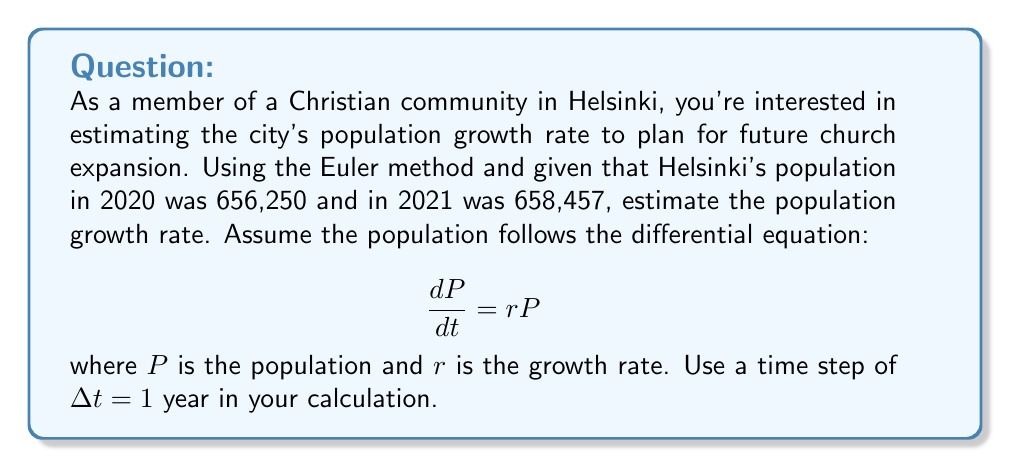Provide a solution to this math problem. To estimate the population growth rate using the Euler method:

1. The Euler method for this differential equation is:
   $$P_{n+1} = P_n + r P_n \Delta t$$

2. We know:
   $P_0 = 656,250$ (2020 population)
   $P_1 = 658,457$ (2021 population)
   $\Delta t = 1$ year

3. Substitute these values into the Euler formula:
   $$658,457 = 656,250 + r(656,250)(1)$$

4. Solve for $r$:
   $$658,457 - 656,250 = 656,250r$$
   $$2,207 = 656,250r$$
   $$r = \frac{2,207}{656,250}$$

5. Calculate $r$:
   $$r \approx 0.003362 \text{ or } 0.3362\%$$

This represents the estimated annual population growth rate for Helsinki.
Answer: $r \approx 0.003362$ or $0.3362\%$ per year 